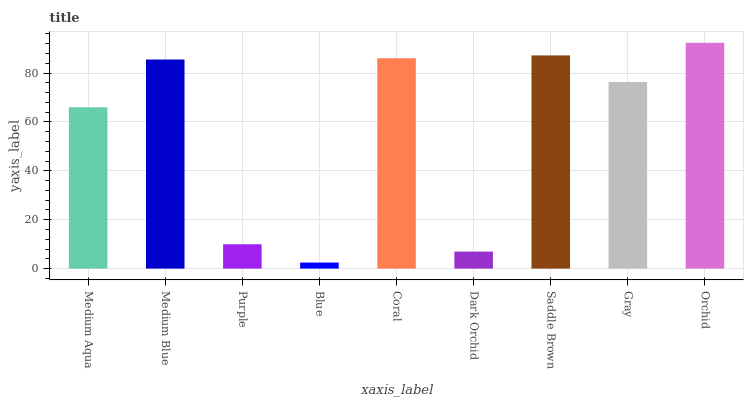Is Blue the minimum?
Answer yes or no. Yes. Is Orchid the maximum?
Answer yes or no. Yes. Is Medium Blue the minimum?
Answer yes or no. No. Is Medium Blue the maximum?
Answer yes or no. No. Is Medium Blue greater than Medium Aqua?
Answer yes or no. Yes. Is Medium Aqua less than Medium Blue?
Answer yes or no. Yes. Is Medium Aqua greater than Medium Blue?
Answer yes or no. No. Is Medium Blue less than Medium Aqua?
Answer yes or no. No. Is Gray the high median?
Answer yes or no. Yes. Is Gray the low median?
Answer yes or no. Yes. Is Medium Blue the high median?
Answer yes or no. No. Is Dark Orchid the low median?
Answer yes or no. No. 